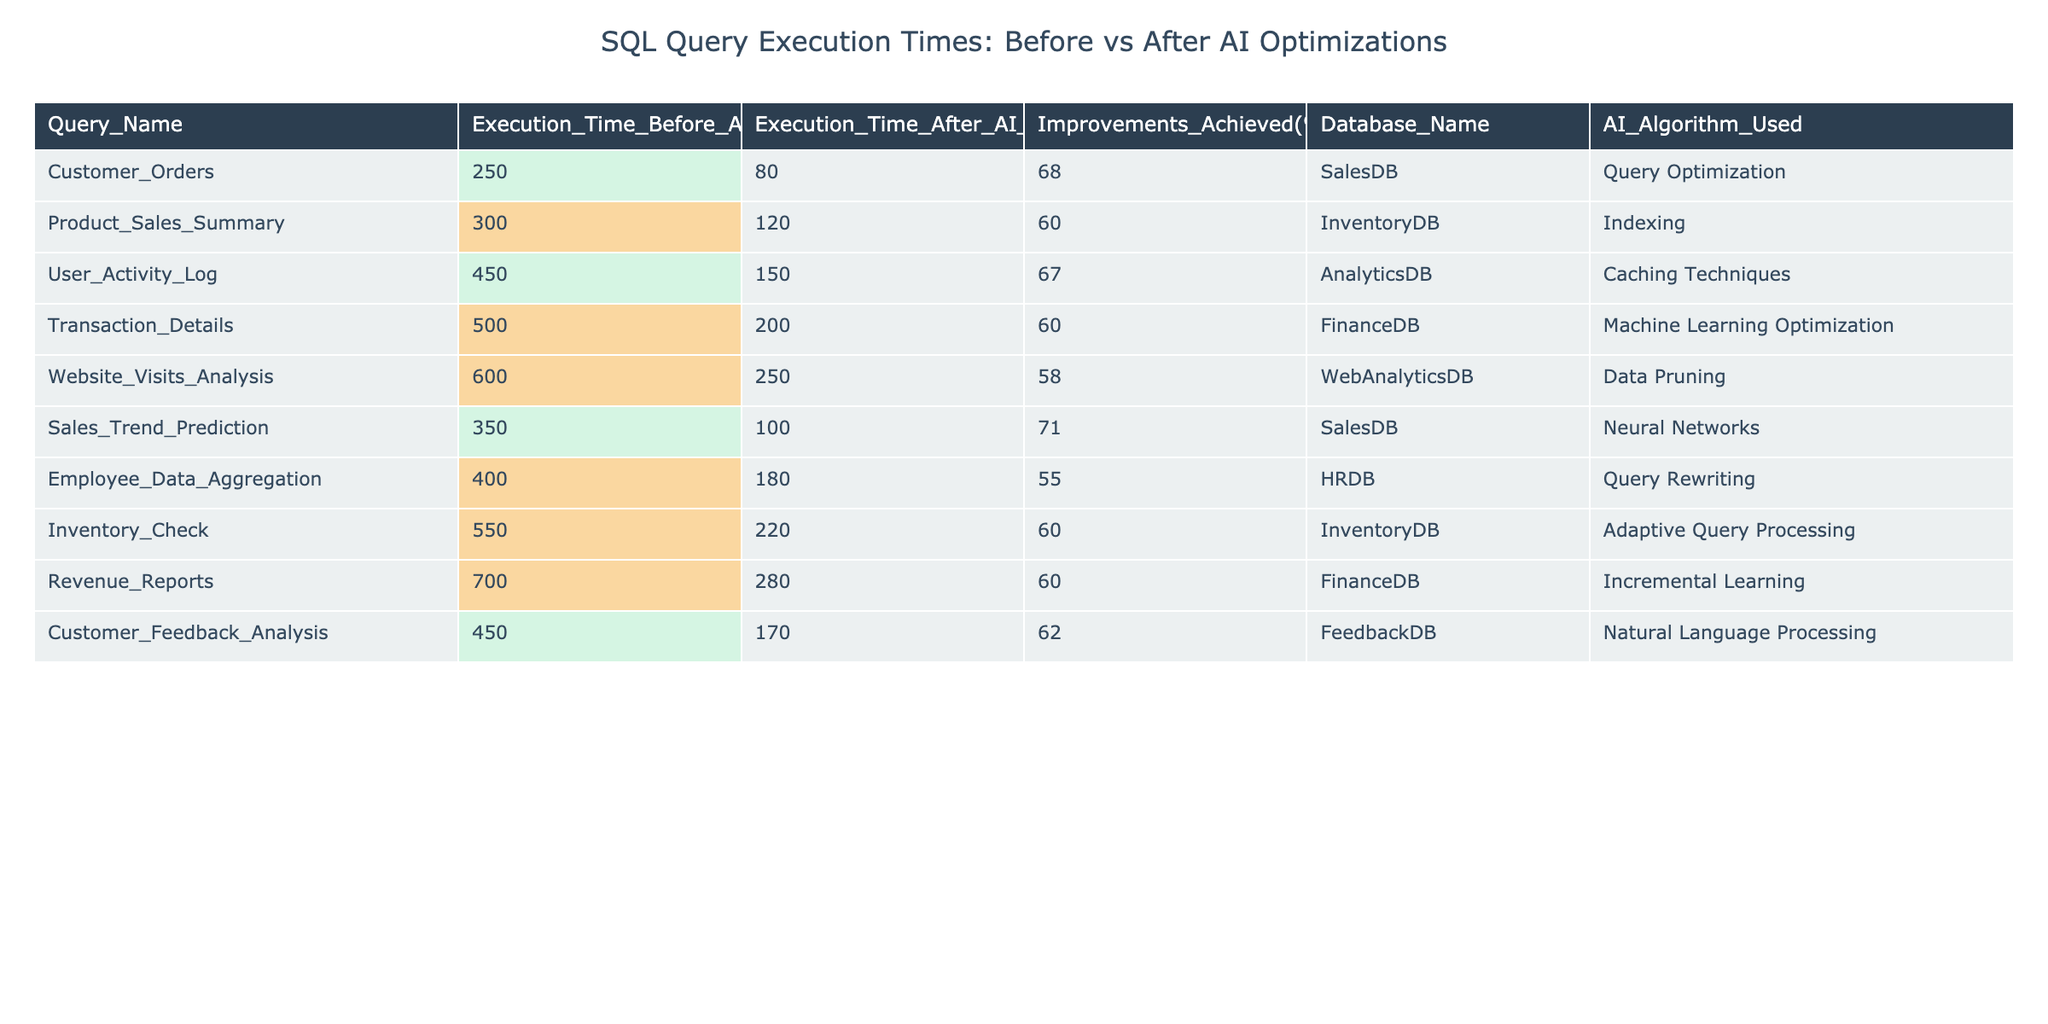What was the execution time for the "Customer_Orders" query before AI optimizations? Looking at the table, under the column "Execution_Time_Before_AI_Opt(ms)", the value for "Customer_Orders" is 250 ms.
Answer: 250 ms What was the percentage improvement for the "Sales_Trend_Prediction" query? The table indicates that the "Improvements_Achieved(%)" for the "Sales_Trend_Prediction" query is 71%.
Answer: 71% Which query had the greatest execution time after AI optimizations? By reviewing the "Execution_Time_After_AI_Opt(ms)" column, the highest value is 280 ms for the "Revenue_Reports" query.
Answer: Revenue_Reports What is the total execution time for all queries before AI optimizations? Summing the values in the "Execution_Time_Before_AI_Opt(ms)" column: 250 + 300 + 450 + 500 + 600 + 350 + 400 + 550 + 700 + 450 = 4300 ms.
Answer: 4300 ms Did any query show an improvement of less than 60%? Looking at the "Improvements_Achieved(%)" column, the queries "Employee_Data_Aggregation", "Website_Visits_Analysis", and "Transaction_Details" had improvements of 55%, 58%, and 60%, respectively, which are less than 60%.
Answer: Yes Which database had the highest execution time before AI optimizations? The query "Website_Visits_Analysis" from the "WebAnalyticsDB" shows the highest "Execution_Time_Before_AI_Opt(ms)" of 600 ms, making this the highest among the databases.
Answer: WebAnalyticsDB What is the average execution time after AI optimizations? The execution times after optimizations are: 80, 120, 150, 200, 250, 100, 180, 220, 280, and 170. The sum is 1,550 ms and dividing by 10 (the number of queries) gives an average of 155 ms.
Answer: 155 ms Is there a query using "Neural Networks" that showed over 70% improvement? Yes, the "Sales_Trend_Prediction" query utilized "Neural Networks" and achieved an improvement of 71%.
Answer: Yes Which queries had an execution time difference of over 300 ms before and after AI optimizations? Comparing execution times, "Website_Visits_Analysis" (600 ms - 250 ms = 350 ms) and "Revenue_Reports" (700 ms - 280 ms = 420 ms) both had differences exceeding 300 ms.
Answer: Website_Visits_Analysis and Revenue_Reports What is the overall improvement percentage across all queries? The total improvements can be determined using the sum of all improvements: 68 + 60 + 67 + 60 + 58 + 71 + 55 + 60 + 60 + 62 =  637%. Dividing by the number of queries (10) gives an overall percentage of 63.7%.
Answer: 63.7% 